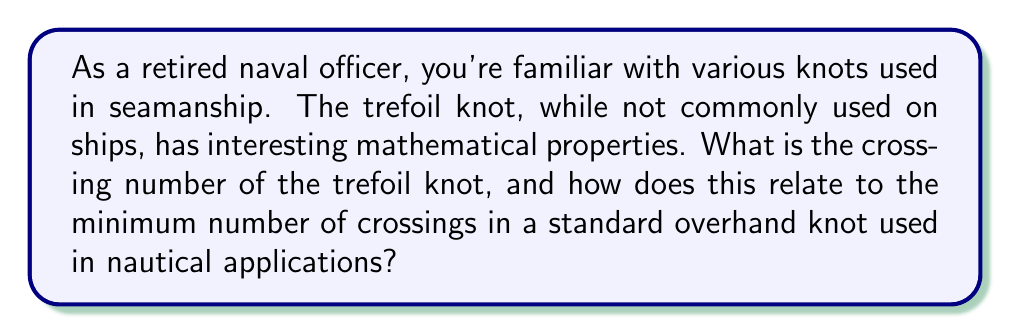Show me your answer to this math problem. To determine the crossing number of the trefoil knot and its significance in nautical knots, let's follow these steps:

1. Define the trefoil knot:
   The trefoil knot is the simplest non-trivial knot in knot theory. It can be represented as a closed loop with three crossings.

2. Determine the crossing number:
   The crossing number of a knot is the minimum number of crossings that occur in any projection of the knot onto a plane. For the trefoil knot:
   
   a) Any diagram of the trefoil knot must have at least 3 crossings.
   b) There exists a diagram of the trefoil knot with exactly 3 crossings.
   c) Therefore, the crossing number of the trefoil knot is 3.

3. Prove the crossing number:
   The proof that the trefoil knot's crossing number is 3 involves advanced concepts in knot theory, such as the Jones polynomial. However, it has been rigorously proven that no projection of the trefoil knot can have fewer than 3 crossings.

4. Compare to nautical knots:
   The standard overhand knot, commonly used in nautical applications, also has a crossing number of 3. This can be seen when the knot is pulled tight:

   [asy]
   import geometry;

   path p = (0,0)..(-1,1)..(0,2)..(1,1)..(0,0);
   draw(p, linewidth(2));
   draw((0,0)--(0,2), linewidth(2));
   label("1", (-0.5,0.5), E);
   label("2", (0.5,0.5), W);
   label("3", (0,1.5), E);
   [/asy]

5. Significance in nautical applications:
   a) The minimum number of crossings (3) in both the trefoil and overhand knot contributes to their stability and security.
   b) In nautical use, the overhand knot serves as a stopper knot, preventing a rope from slipping through a hole or block.
   c) The trefoil knot's mathematical properties, while not directly applicable in seamanship, demonstrate fundamental principles of knot complexity that underlie the effectiveness of nautical knots.

6. Mathematical representation:
   The trefoil knot can be described parametrically as:

   $$x = \sin t + 2 \sin 2t$$
   $$y = \cos t - 2 \cos 2t$$
   $$z = -\sin 3t$$

   where $0 \leq t \leq 2\pi$

This mathematical description showcases the complexity inherent in even simple knots, which is relevant to understanding the properties of more complex nautical knots.
Answer: Crossing number: 3; Significance: Minimum crossings for stability in nautical knots 